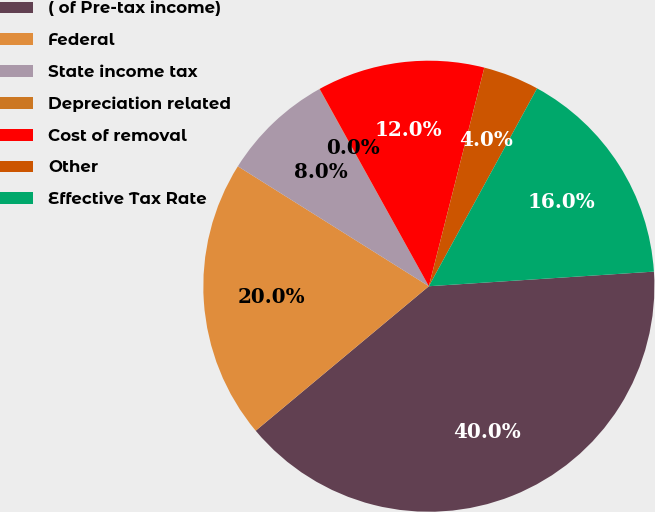Convert chart to OTSL. <chart><loc_0><loc_0><loc_500><loc_500><pie_chart><fcel>( of Pre-tax income)<fcel>Federal<fcel>State income tax<fcel>Depreciation related<fcel>Cost of removal<fcel>Other<fcel>Effective Tax Rate<nl><fcel>39.96%<fcel>19.99%<fcel>8.01%<fcel>0.02%<fcel>12.0%<fcel>4.01%<fcel>16.0%<nl></chart> 